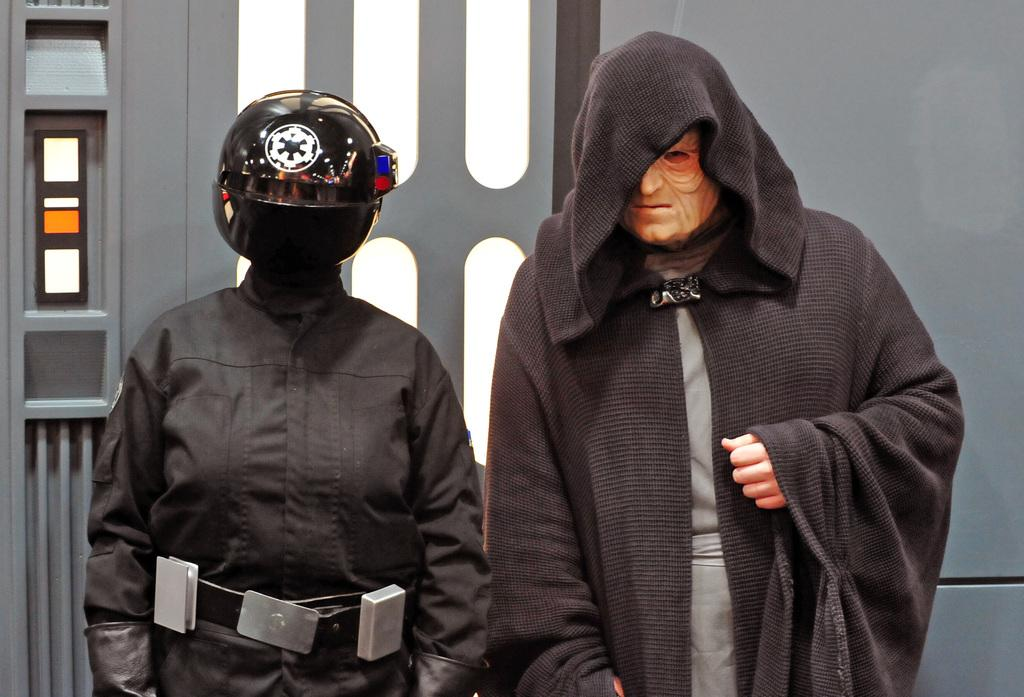What is on the right side of the image? There is a person wearing a costume on the right side of the image. What can be seen on the left side of the image? There might be a person wearing a black color dress and a helmet on the left side of the image. What type of train can be seen in the background of the image? There is no train present in the image. What scene is depicted in the image? The image does not depict a specific scene; it shows two people, one wearing a costume and the other possibly wearing a black dress and a helmet. 